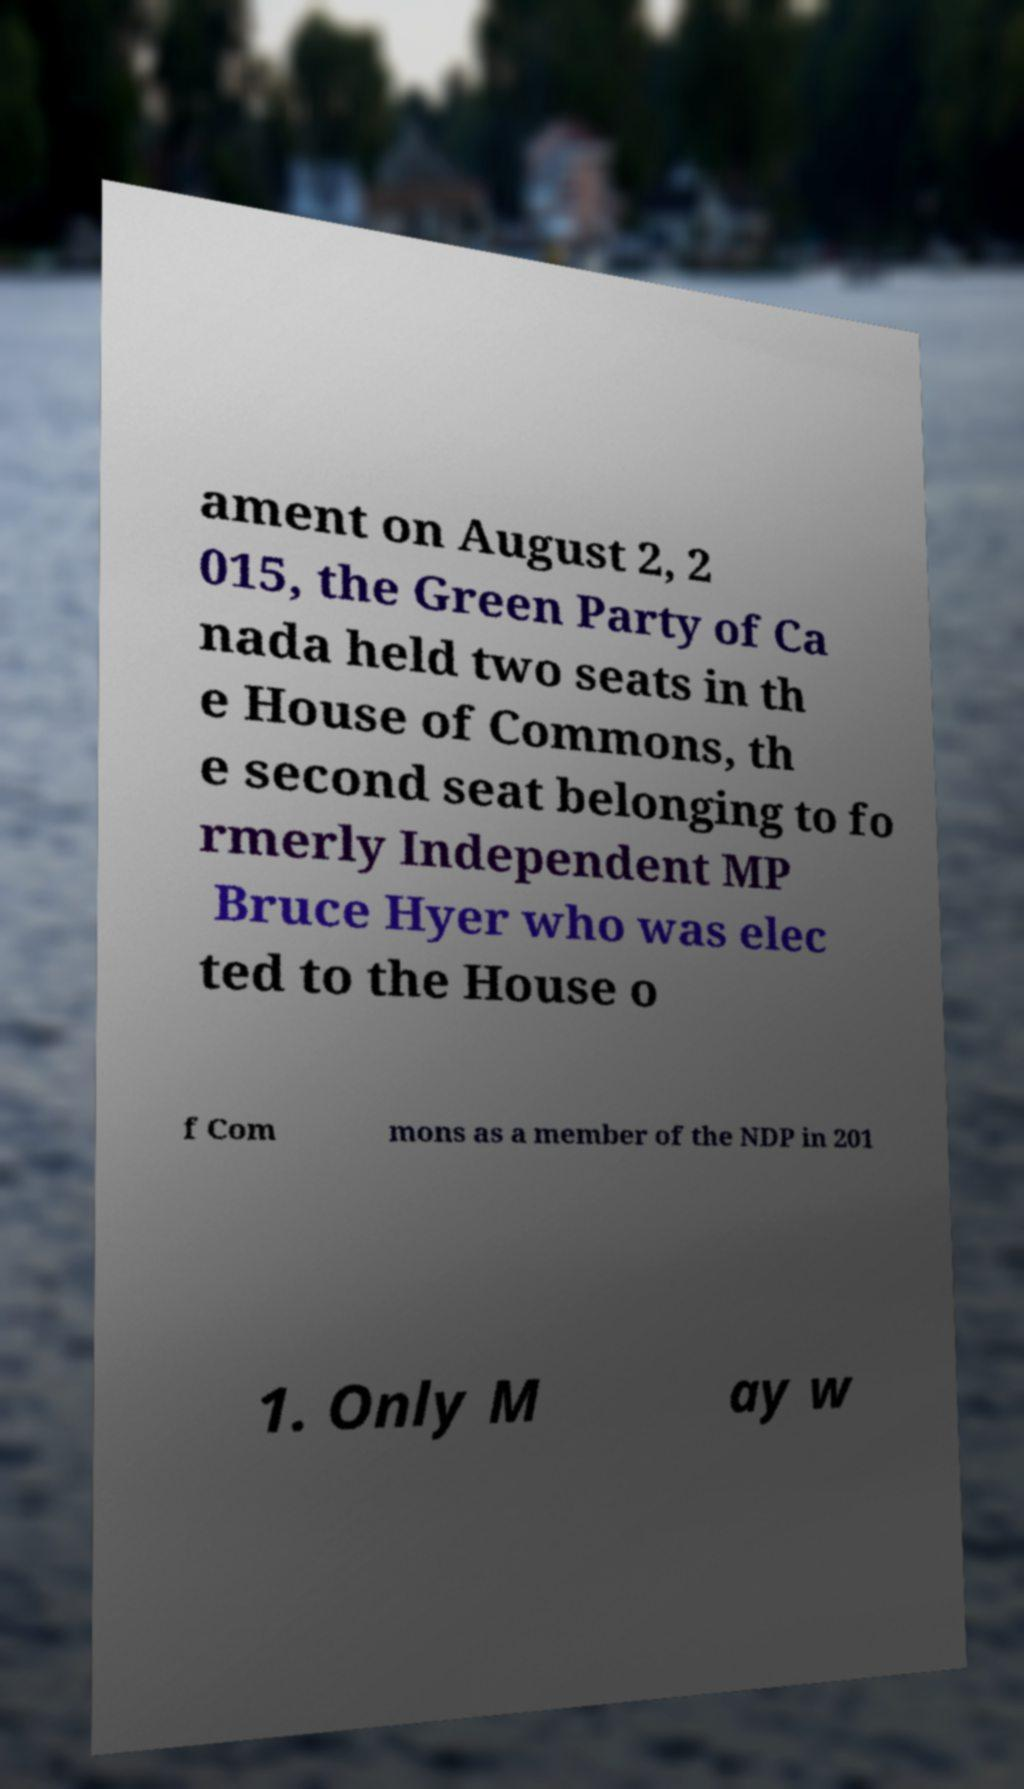Could you assist in decoding the text presented in this image and type it out clearly? ament on August 2, 2 015, the Green Party of Ca nada held two seats in th e House of Commons, th e second seat belonging to fo rmerly Independent MP Bruce Hyer who was elec ted to the House o f Com mons as a member of the NDP in 201 1. Only M ay w 